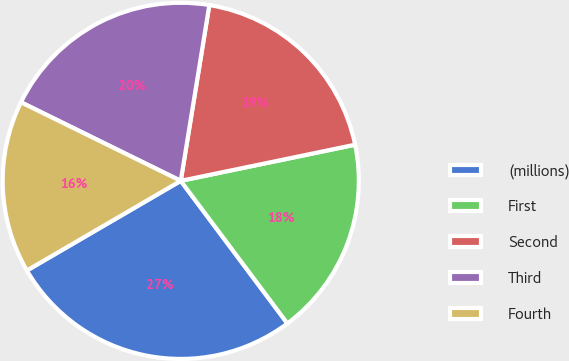Convert chart. <chart><loc_0><loc_0><loc_500><loc_500><pie_chart><fcel>(millions)<fcel>First<fcel>Second<fcel>Third<fcel>Fourth<nl><fcel>26.82%<fcel>18.03%<fcel>19.18%<fcel>20.29%<fcel>15.67%<nl></chart> 